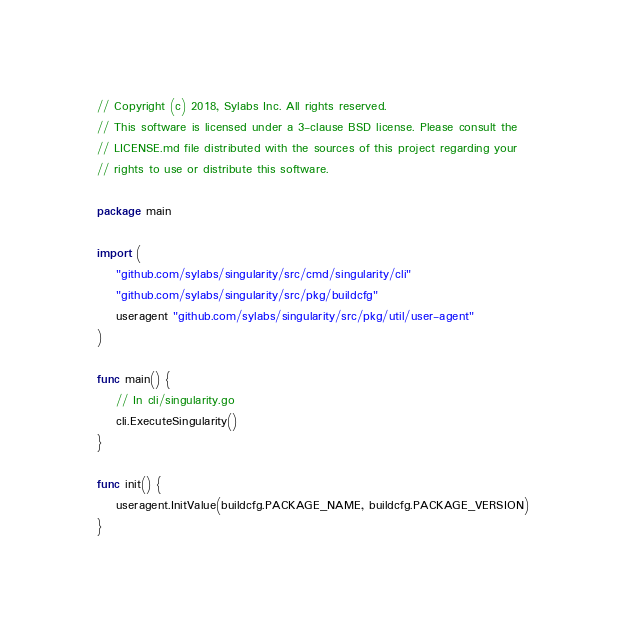Convert code to text. <code><loc_0><loc_0><loc_500><loc_500><_Go_>// Copyright (c) 2018, Sylabs Inc. All rights reserved.
// This software is licensed under a 3-clause BSD license. Please consult the
// LICENSE.md file distributed with the sources of this project regarding your
// rights to use or distribute this software.

package main

import (
	"github.com/sylabs/singularity/src/cmd/singularity/cli"
	"github.com/sylabs/singularity/src/pkg/buildcfg"
	useragent "github.com/sylabs/singularity/src/pkg/util/user-agent"
)

func main() {
	// In cli/singularity.go
	cli.ExecuteSingularity()
}

func init() {
	useragent.InitValue(buildcfg.PACKAGE_NAME, buildcfg.PACKAGE_VERSION)
}
</code> 